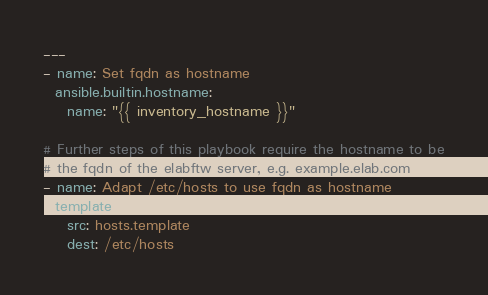Convert code to text. <code><loc_0><loc_0><loc_500><loc_500><_YAML_>---
- name: Set fqdn as hostname
  ansible.builtin.hostname:
    name: "{{ inventory_hostname }}"

# Further steps of this playbook require the hostname to be
# the fqdn of the elabftw server, e.g. example.elab.com
- name: Adapt /etc/hosts to use fqdn as hostname
  template:
    src: hosts.template
    dest: /etc/hosts
</code> 